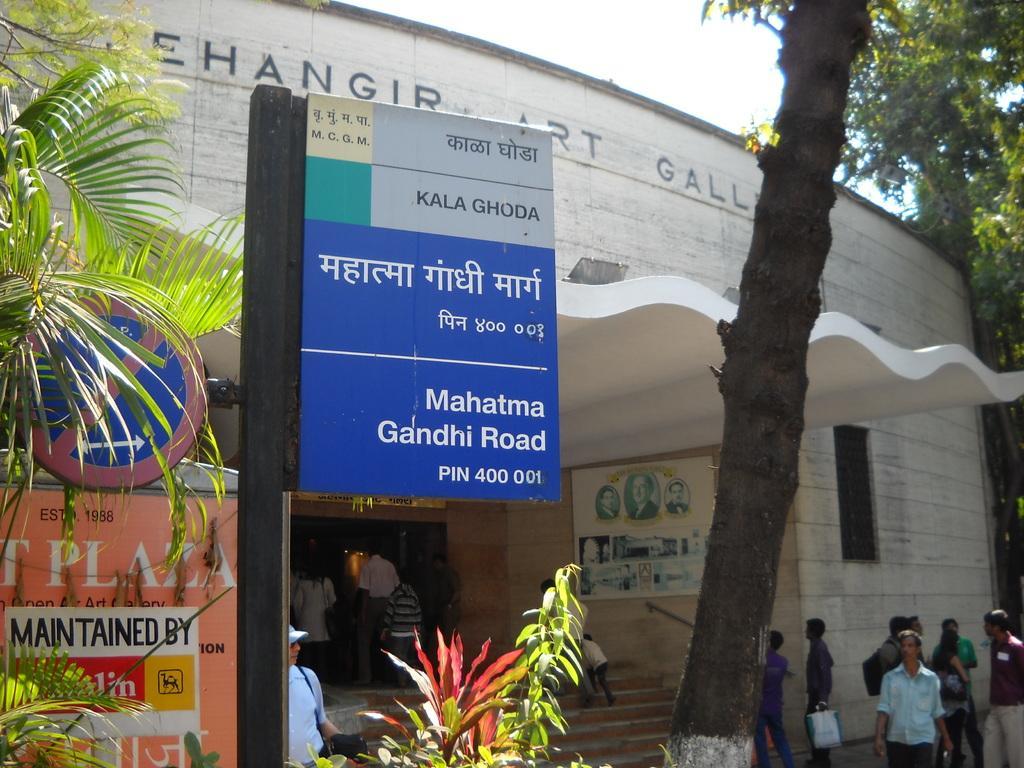Could you give a brief overview of what you see in this image? In this image we can see a building. There is a sign board, an advertising board, an address board and a notice board. There are few plants and trees in the image. There are many people in the image. 